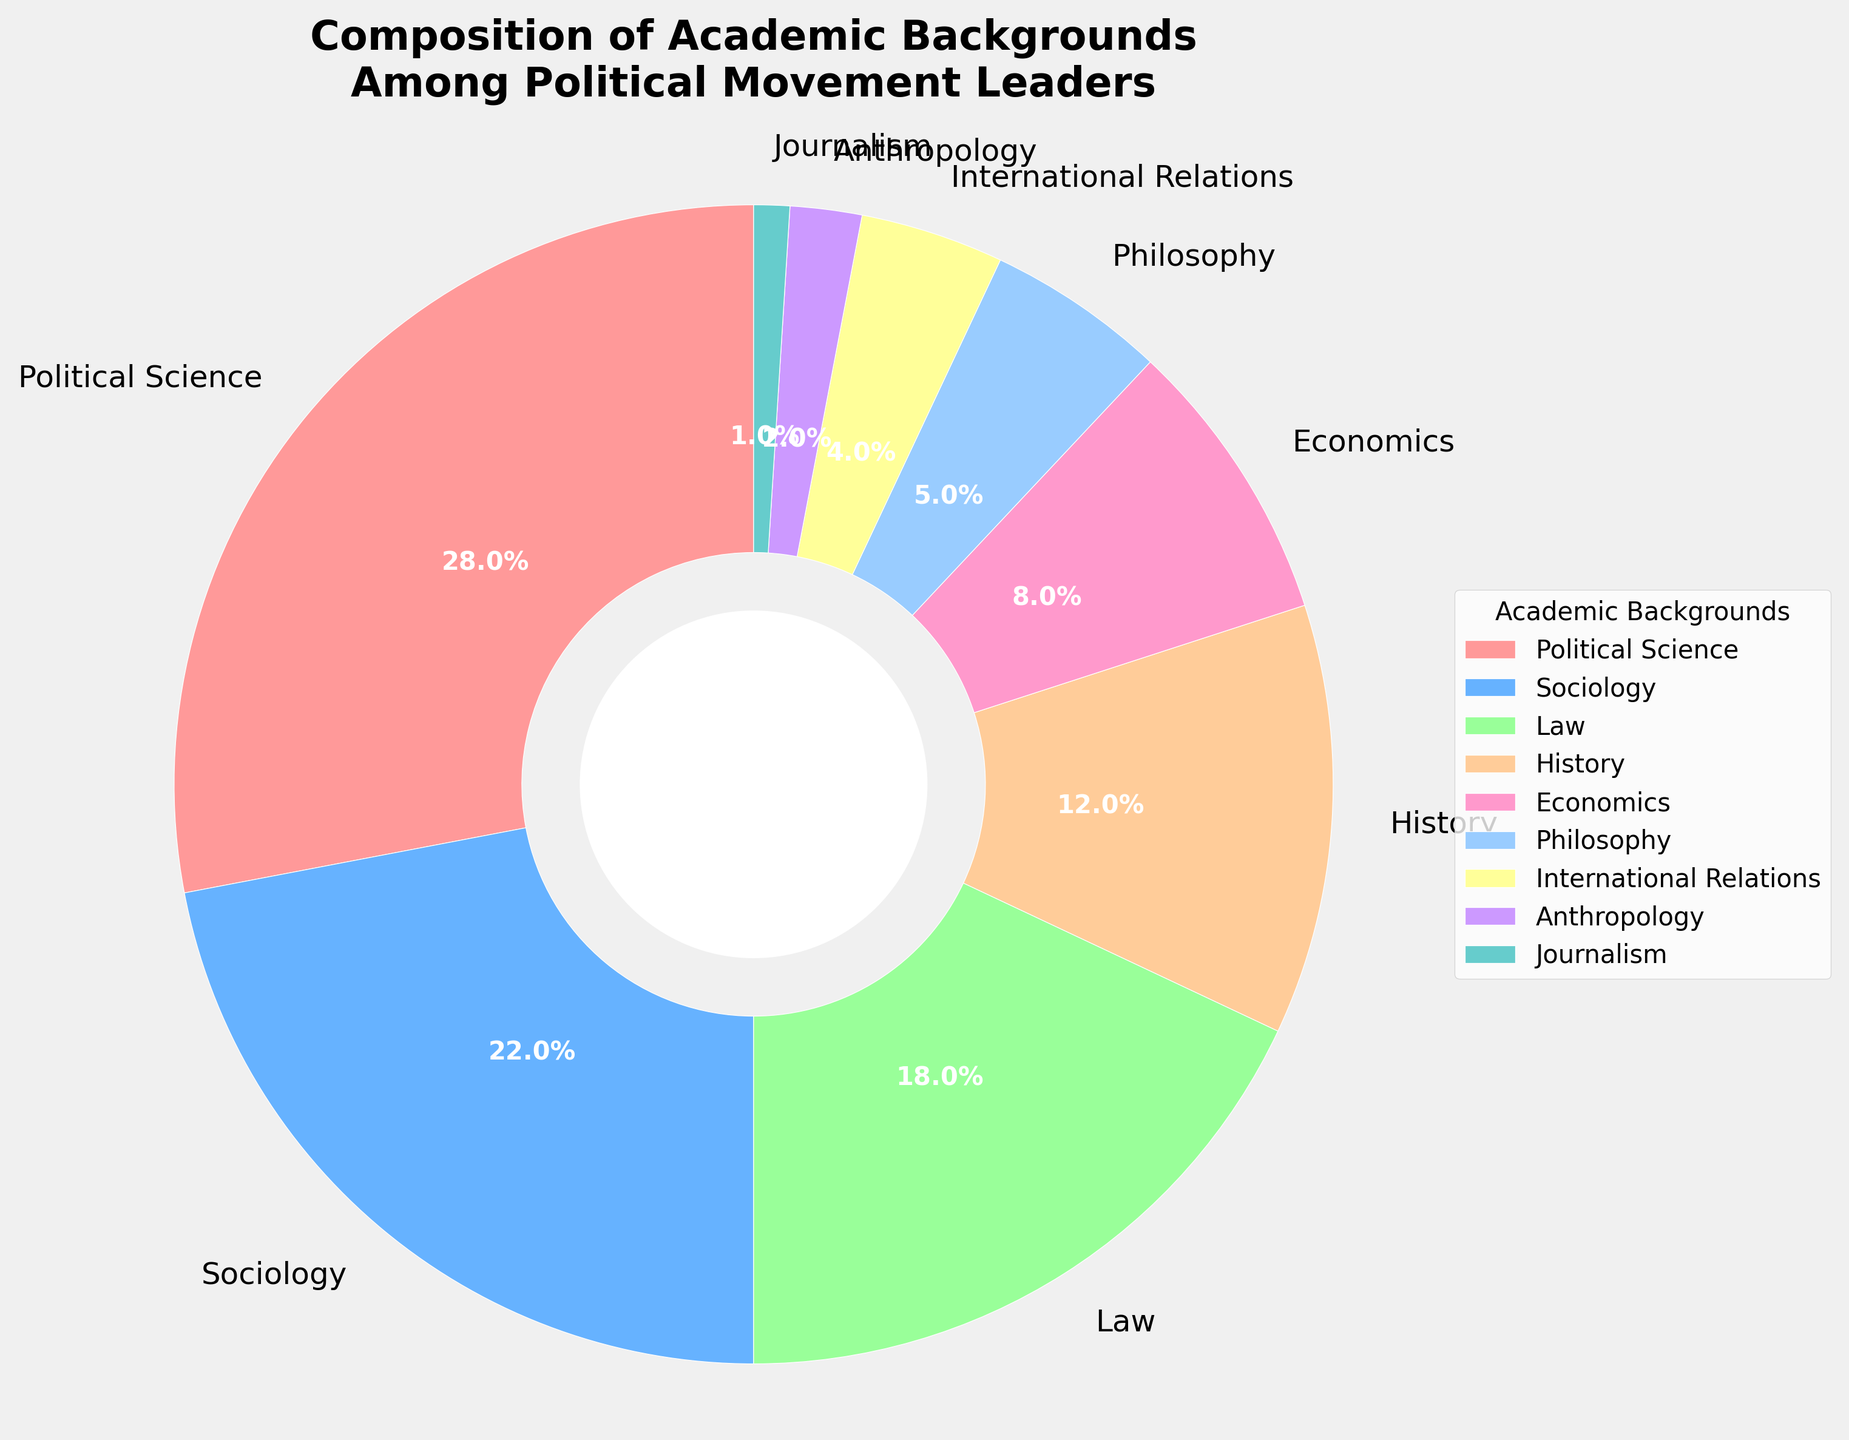what percentage of political movement leaders have a background in law and history combined? Sum the percentages for Law and History: 18% + 12% = 30%
Answer: 30% Which academic background has the lowest percentage of political movement leaders? The lowest percentage is 1%, which corresponds to Journalism
Answer: Journalism What are the three most common academic backgrounds among political movement leaders? The three highest percentages are Political Science (28%), Sociology (22%), and Law (18%)
Answer: Political Science, Sociology, Law Which academic background has a greater percentage, Economics or Philosophy? Economics is 8% and Philosophy is 5%. Since 8% > 5%, Economics has a greater percentage
Answer: Economics How much greater is the percentage of leaders with a Political Science background compared to those with an Economics background? Subtract the percentage of Economics from Political Science: 28% - 8% = 20%
Answer: 20% Are there more political movement leaders with a background in History than those in International Relations and Anthropology combined? History is 12%, International Relations is 4%, and Anthropology is 2%. Combined, International Relations and Anthropology have 4% + 2% = 6%, which is less than History's 12%
Answer: Yes What percentage of political movement leaders have backgrounds either in Journalism or Anthropology? Sum the percentages for Journalism and Anthropology: 1% + 2% = 3%
Answer: 3% Which segment of the pie chart is represented by the color red? The color red represents Political Science
Answer: Political Science Is the percentage of leaders with a Sociology background more or less than twice the percentage of those with an Economics background? Twice the percentage of Economics is 2 * 8% = 16%. Sociology is 22%, which is more than 16%
Answer: More What is the average percentage of leaders from backgrounds in Philosophy, International Relations, and Anthropology? Sum percentages of Philosophy, International Relations, and Anthropology: 5% + 4% + 2% = 11%. Average is 11% / 3 ≈ 3.67%
Answer: 3.67% 